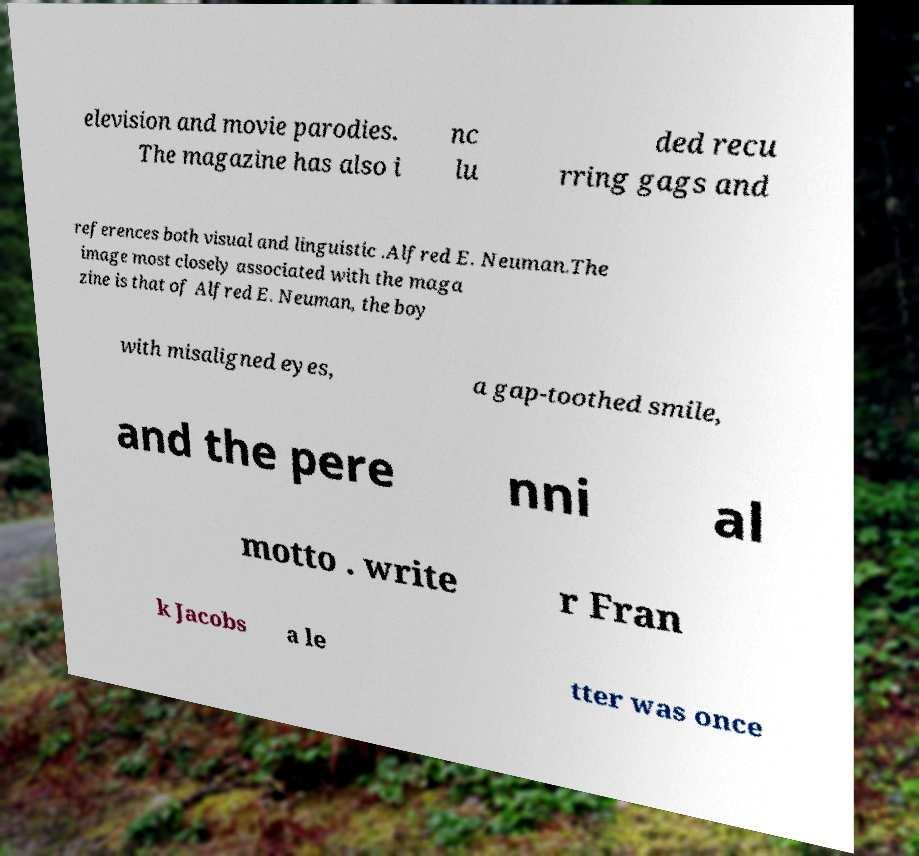Could you assist in decoding the text presented in this image and type it out clearly? elevision and movie parodies. The magazine has also i nc lu ded recu rring gags and references both visual and linguistic .Alfred E. Neuman.The image most closely associated with the maga zine is that of Alfred E. Neuman, the boy with misaligned eyes, a gap-toothed smile, and the pere nni al motto . write r Fran k Jacobs a le tter was once 